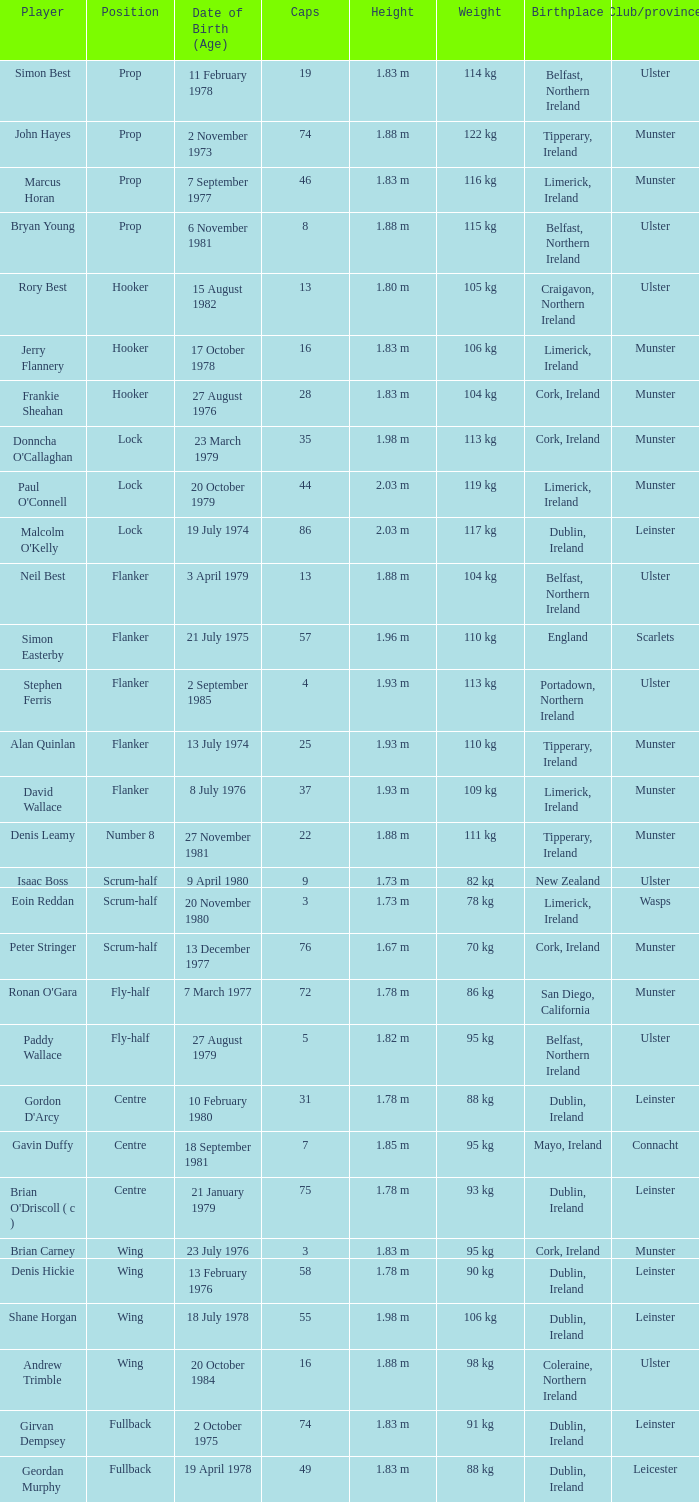What is the club or province of Girvan Dempsey, who has 74 caps? Leinster. 